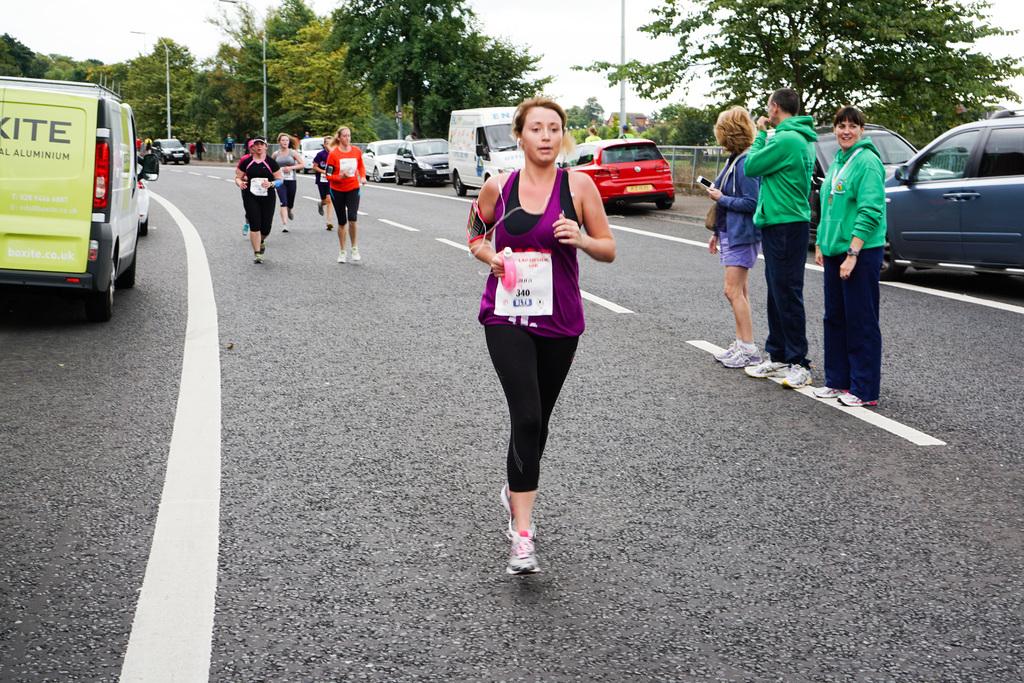What number is the woman in purple?
Give a very brief answer. 340. What is the first line on the back of the van?
Provide a succinct answer. Kite. 